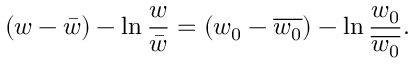Convert formula to latex. <formula><loc_0><loc_0><loc_500><loc_500>( w - \bar { w } ) - \ln \frac { w } { \bar { w } } = ( w _ { 0 } - \overline { { w _ { 0 } } } ) - \ln \frac { w _ { 0 } } { \overline { { w _ { 0 } } } } .</formula> 